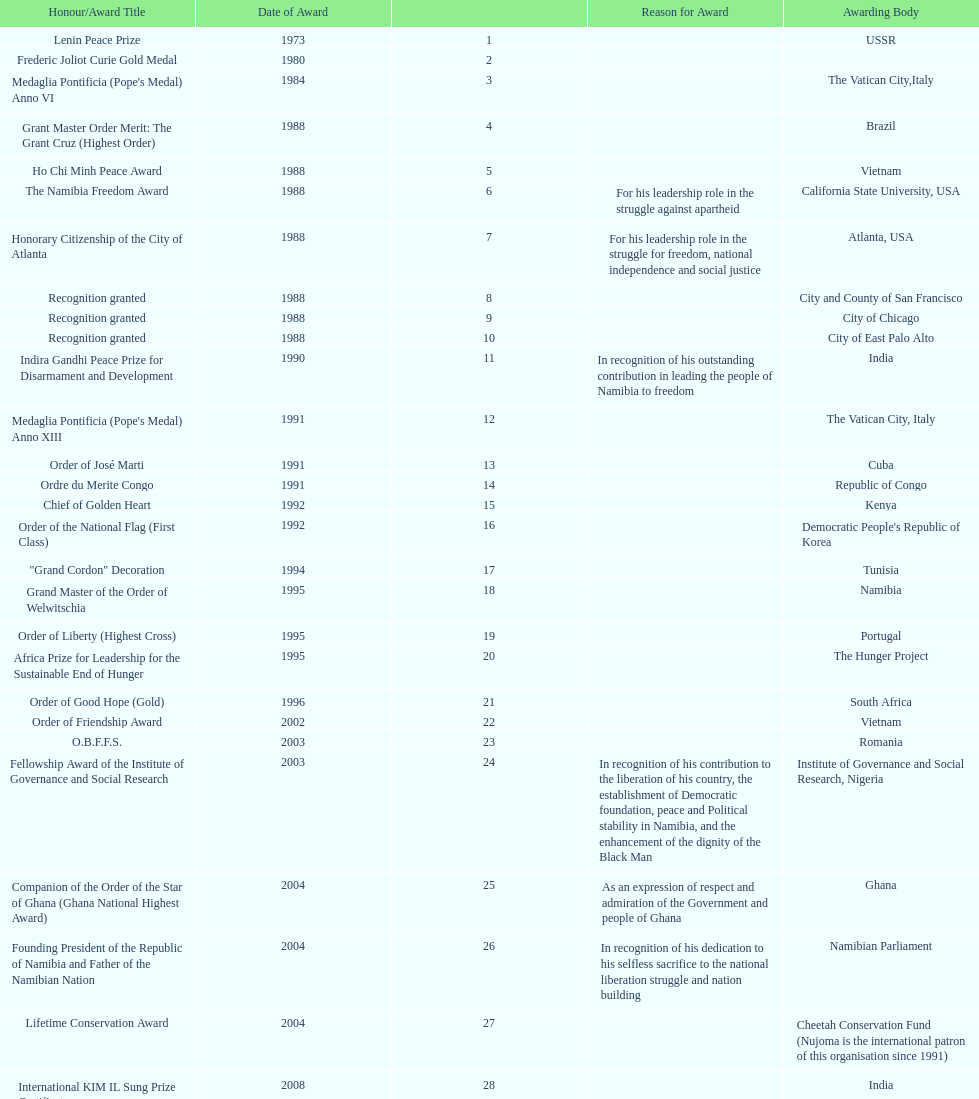In which country, romania or ghana, was the o.b.f.f.s. award won by nujoma? Romania. 